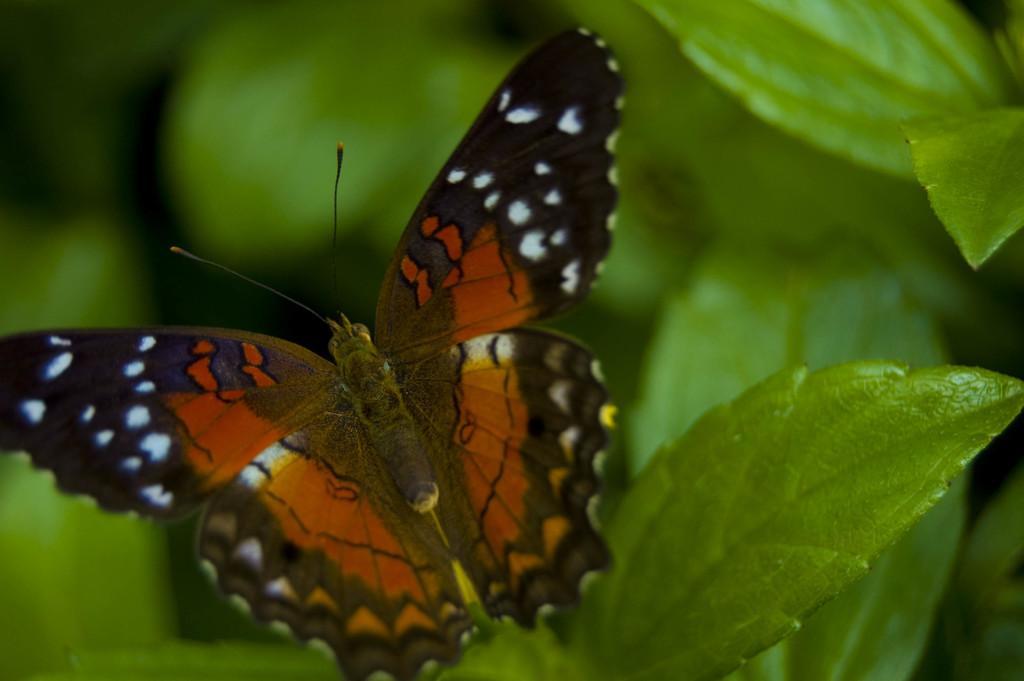How would you summarize this image in a sentence or two? In this image in the foreground there is one butterfly on a leaf, and there is blurred background. 